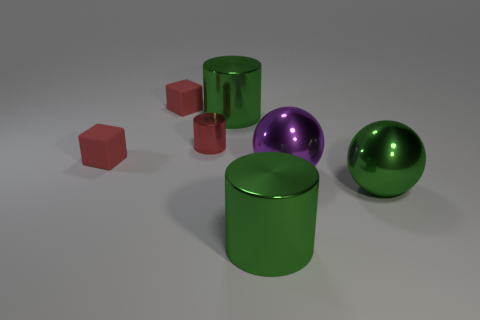Add 2 red cylinders. How many objects exist? 9 Subtract all blocks. How many objects are left? 5 Subtract 0 cyan cylinders. How many objects are left? 7 Subtract all big green metallic spheres. Subtract all large shiny cylinders. How many objects are left? 4 Add 6 red cylinders. How many red cylinders are left? 7 Add 7 red metallic cylinders. How many red metallic cylinders exist? 8 